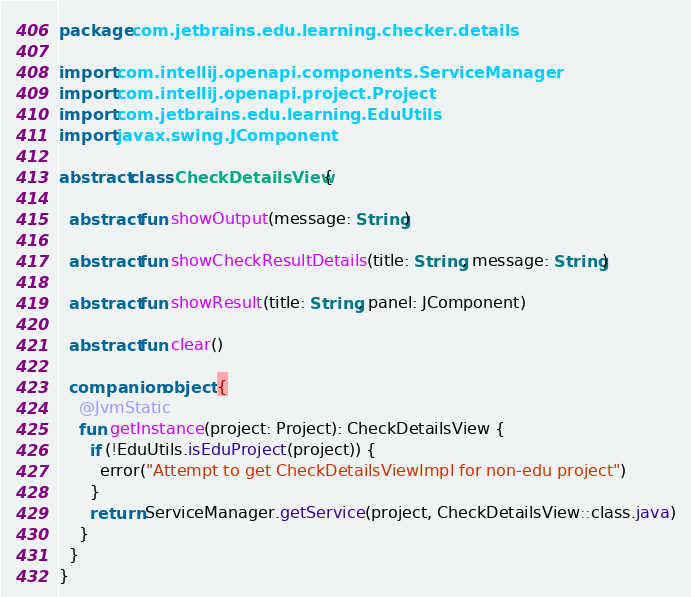<code> <loc_0><loc_0><loc_500><loc_500><_Kotlin_>package com.jetbrains.edu.learning.checker.details

import com.intellij.openapi.components.ServiceManager
import com.intellij.openapi.project.Project
import com.jetbrains.edu.learning.EduUtils
import javax.swing.JComponent

abstract class CheckDetailsView {

  abstract fun showOutput(message: String)

  abstract fun showCheckResultDetails(title: String, message: String)

  abstract fun showResult(title: String, panel: JComponent)

  abstract fun clear()

  companion object {
    @JvmStatic
    fun getInstance(project: Project): CheckDetailsView {
      if (!EduUtils.isEduProject(project)) {
        error("Attempt to get CheckDetailsViewImpl for non-edu project")
      }
      return ServiceManager.getService(project, CheckDetailsView::class.java)
    }
  }
}</code> 